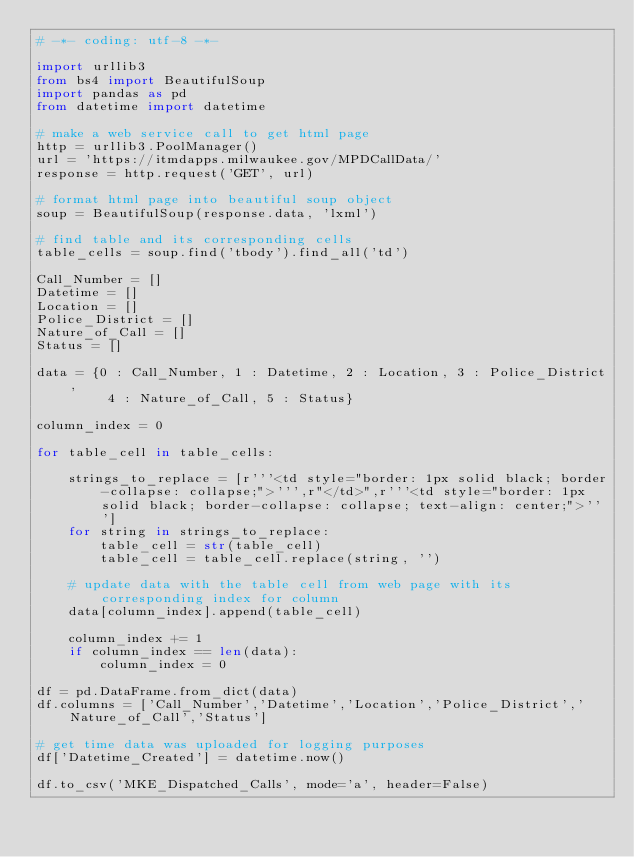Convert code to text. <code><loc_0><loc_0><loc_500><loc_500><_Python_># -*- coding: utf-8 -*-

import urllib3
from bs4 import BeautifulSoup
import pandas as pd
from datetime import datetime

# make a web service call to get html page
http = urllib3.PoolManager()
url = 'https://itmdapps.milwaukee.gov/MPDCallData/'
response = http.request('GET', url)

# format html page into beautiful soup object
soup = BeautifulSoup(response.data, 'lxml')

# find table and its corresponding cells
table_cells = soup.find('tbody').find_all('td')

Call_Number = []
Datetime = []
Location = []
Police_District = []
Nature_of_Call = []
Status = []

data = {0 : Call_Number, 1 : Datetime, 2 : Location, 3 : Police_District, 
         4 : Nature_of_Call, 5 : Status}

column_index = 0

for table_cell in table_cells:
    
    strings_to_replace = [r'''<td style="border: 1px solid black; border-collapse: collapse;">''',r"</td>",r'''<td style="border: 1px solid black; border-collapse: collapse; text-align: center;">''']
    for string in strings_to_replace:
        table_cell = str(table_cell)
        table_cell = table_cell.replace(string, '')
    
    # update data with the table cell from web page with its corresponding index for column
    data[column_index].append(table_cell)
    
    column_index += 1
    if column_index == len(data):
        column_index = 0
        
df = pd.DataFrame.from_dict(data)
df.columns = ['Call_Number','Datetime','Location','Police_District','Nature_of_Call','Status']

# get time data was uploaded for logging purposes
df['Datetime_Created'] = datetime.now()

df.to_csv('MKE_Dispatched_Calls', mode='a', header=False)
</code> 